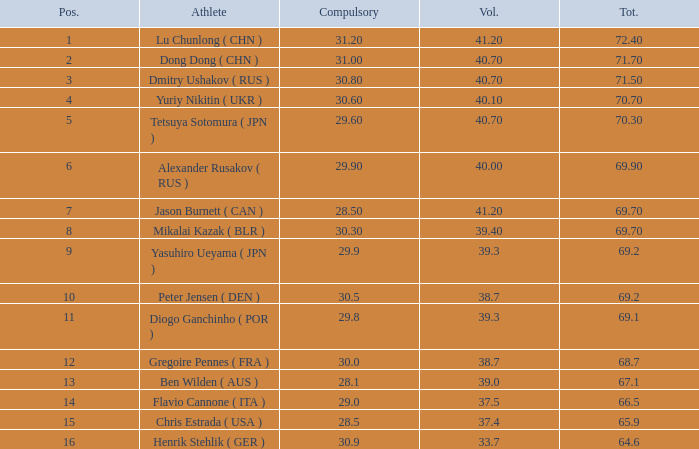Write the full table. {'header': ['Pos.', 'Athlete', 'Compulsory', 'Vol.', 'Tot.'], 'rows': [['1', 'Lu Chunlong ( CHN )', '31.20', '41.20', '72.40'], ['2', 'Dong Dong ( CHN )', '31.00', '40.70', '71.70'], ['3', 'Dmitry Ushakov ( RUS )', '30.80', '40.70', '71.50'], ['4', 'Yuriy Nikitin ( UKR )', '30.60', '40.10', '70.70'], ['5', 'Tetsuya Sotomura ( JPN )', '29.60', '40.70', '70.30'], ['6', 'Alexander Rusakov ( RUS )', '29.90', '40.00', '69.90'], ['7', 'Jason Burnett ( CAN )', '28.50', '41.20', '69.70'], ['8', 'Mikalai Kazak ( BLR )', '30.30', '39.40', '69.70'], ['9', 'Yasuhiro Ueyama ( JPN )', '29.9', '39.3', '69.2'], ['10', 'Peter Jensen ( DEN )', '30.5', '38.7', '69.2'], ['11', 'Diogo Ganchinho ( POR )', '29.8', '39.3', '69.1'], ['12', 'Gregoire Pennes ( FRA )', '30.0', '38.7', '68.7'], ['13', 'Ben Wilden ( AUS )', '28.1', '39.0', '67.1'], ['14', 'Flavio Cannone ( ITA )', '29.0', '37.5', '66.5'], ['15', 'Chris Estrada ( USA )', '28.5', '37.4', '65.9'], ['16', 'Henrik Stehlik ( GER )', '30.9', '33.7', '64.6']]} 7? 0.0. 